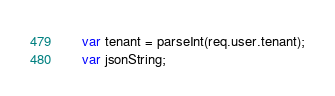<code> <loc_0><loc_0><loc_500><loc_500><_JavaScript_>    var tenant = parseInt(req.user.tenant);
    var jsonString;
</code> 